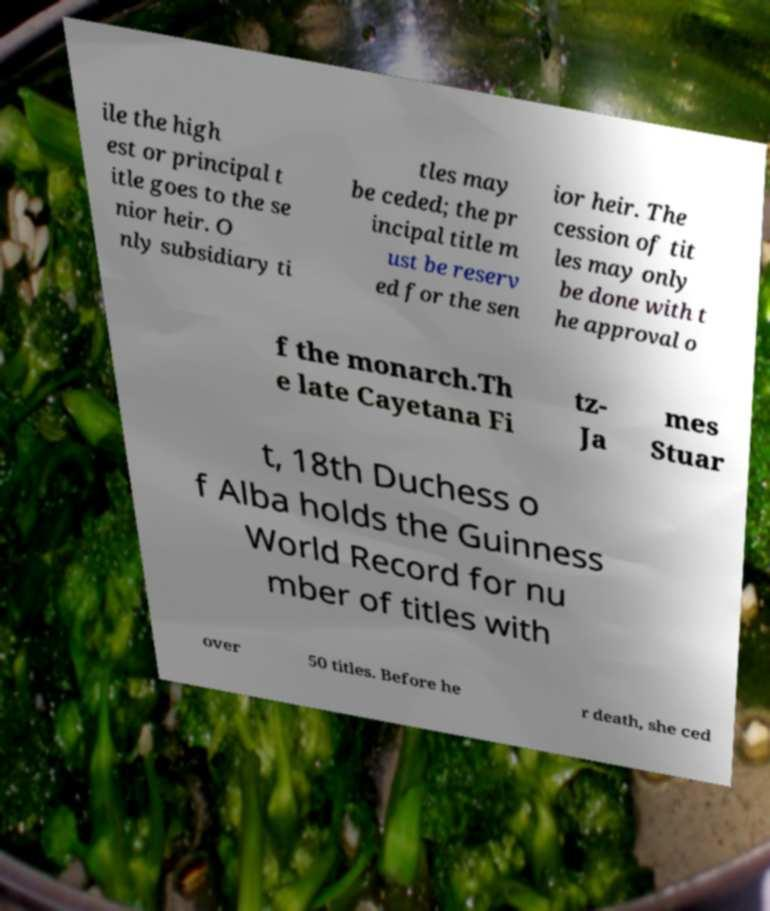For documentation purposes, I need the text within this image transcribed. Could you provide that? ile the high est or principal t itle goes to the se nior heir. O nly subsidiary ti tles may be ceded; the pr incipal title m ust be reserv ed for the sen ior heir. The cession of tit les may only be done with t he approval o f the monarch.Th e late Cayetana Fi tz- Ja mes Stuar t, 18th Duchess o f Alba holds the Guinness World Record for nu mber of titles with over 50 titles. Before he r death, she ced 